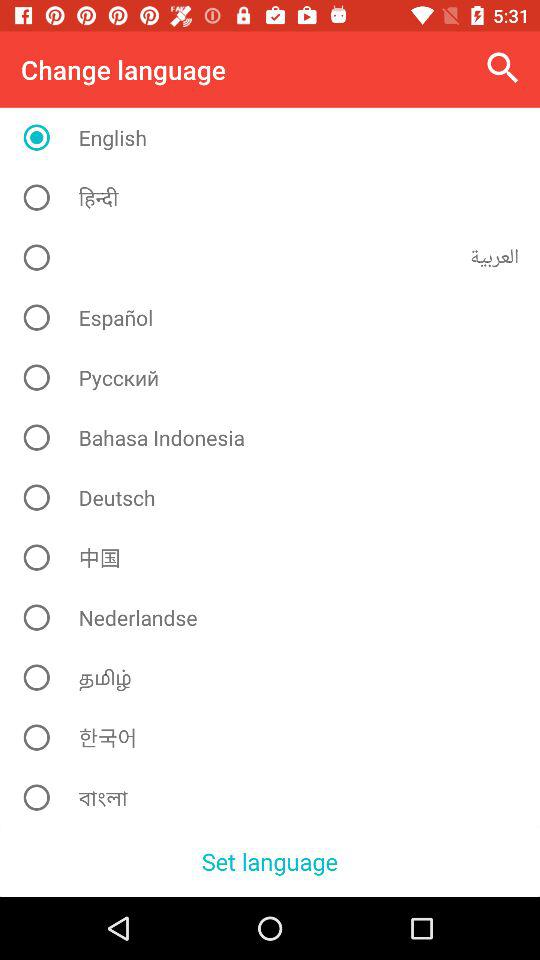Which language was selected? The selected language was English. 